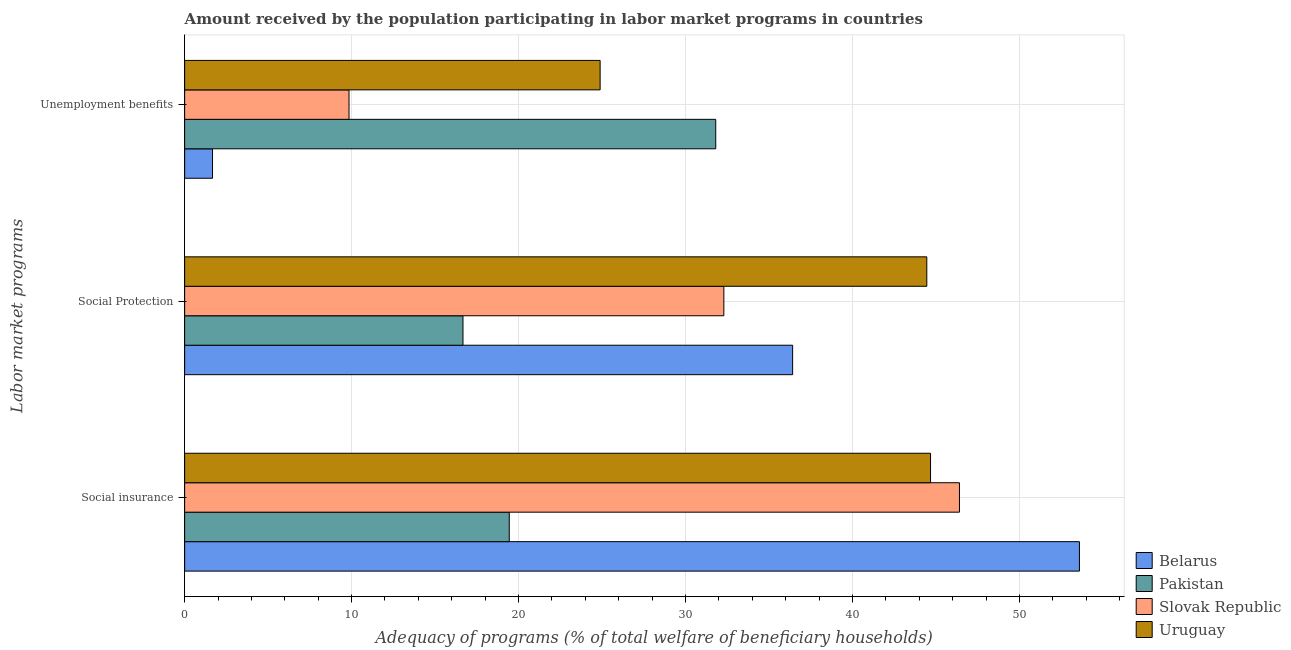How many different coloured bars are there?
Keep it short and to the point. 4. How many groups of bars are there?
Provide a succinct answer. 3. What is the label of the 3rd group of bars from the top?
Give a very brief answer. Social insurance. What is the amount received by the population participating in social protection programs in Pakistan?
Provide a short and direct response. 16.67. Across all countries, what is the maximum amount received by the population participating in social protection programs?
Make the answer very short. 44.45. Across all countries, what is the minimum amount received by the population participating in social insurance programs?
Provide a short and direct response. 19.44. In which country was the amount received by the population participating in social protection programs maximum?
Keep it short and to the point. Uruguay. In which country was the amount received by the population participating in unemployment benefits programs minimum?
Your answer should be compact. Belarus. What is the total amount received by the population participating in social insurance programs in the graph?
Ensure brevity in your answer.  164.13. What is the difference between the amount received by the population participating in social protection programs in Pakistan and that in Uruguay?
Ensure brevity in your answer.  -27.78. What is the difference between the amount received by the population participating in social insurance programs in Slovak Republic and the amount received by the population participating in social protection programs in Uruguay?
Your answer should be compact. 1.96. What is the average amount received by the population participating in unemployment benefits programs per country?
Provide a short and direct response. 17.05. What is the difference between the amount received by the population participating in unemployment benefits programs and amount received by the population participating in social insurance programs in Slovak Republic?
Offer a very short reply. -36.56. In how many countries, is the amount received by the population participating in social protection programs greater than 48 %?
Offer a very short reply. 0. What is the ratio of the amount received by the population participating in social insurance programs in Uruguay to that in Pakistan?
Offer a very short reply. 2.3. Is the difference between the amount received by the population participating in social protection programs in Slovak Republic and Pakistan greater than the difference between the amount received by the population participating in unemployment benefits programs in Slovak Republic and Pakistan?
Offer a terse response. Yes. What is the difference between the highest and the second highest amount received by the population participating in social insurance programs?
Offer a very short reply. 7.19. What is the difference between the highest and the lowest amount received by the population participating in social insurance programs?
Offer a terse response. 34.15. In how many countries, is the amount received by the population participating in unemployment benefits programs greater than the average amount received by the population participating in unemployment benefits programs taken over all countries?
Give a very brief answer. 2. Is the sum of the amount received by the population participating in unemployment benefits programs in Slovak Republic and Belarus greater than the maximum amount received by the population participating in social insurance programs across all countries?
Offer a terse response. No. What does the 1st bar from the top in Unemployment benefits represents?
Your answer should be very brief. Uruguay. What does the 1st bar from the bottom in Social insurance represents?
Provide a succinct answer. Belarus. Are all the bars in the graph horizontal?
Your answer should be compact. Yes. How many countries are there in the graph?
Ensure brevity in your answer.  4. Does the graph contain any zero values?
Provide a short and direct response. No. Where does the legend appear in the graph?
Give a very brief answer. Bottom right. How many legend labels are there?
Your response must be concise. 4. What is the title of the graph?
Give a very brief answer. Amount received by the population participating in labor market programs in countries. What is the label or title of the X-axis?
Provide a short and direct response. Adequacy of programs (% of total welfare of beneficiary households). What is the label or title of the Y-axis?
Offer a terse response. Labor market programs. What is the Adequacy of programs (% of total welfare of beneficiary households) in Belarus in Social insurance?
Make the answer very short. 53.6. What is the Adequacy of programs (% of total welfare of beneficiary households) in Pakistan in Social insurance?
Offer a terse response. 19.44. What is the Adequacy of programs (% of total welfare of beneficiary households) of Slovak Republic in Social insurance?
Your response must be concise. 46.41. What is the Adequacy of programs (% of total welfare of beneficiary households) of Uruguay in Social insurance?
Give a very brief answer. 44.68. What is the Adequacy of programs (% of total welfare of beneficiary households) of Belarus in Social Protection?
Offer a very short reply. 36.42. What is the Adequacy of programs (% of total welfare of beneficiary households) in Pakistan in Social Protection?
Provide a short and direct response. 16.67. What is the Adequacy of programs (% of total welfare of beneficiary households) in Slovak Republic in Social Protection?
Offer a very short reply. 32.3. What is the Adequacy of programs (% of total welfare of beneficiary households) of Uruguay in Social Protection?
Your answer should be compact. 44.45. What is the Adequacy of programs (% of total welfare of beneficiary households) in Belarus in Unemployment benefits?
Ensure brevity in your answer.  1.67. What is the Adequacy of programs (% of total welfare of beneficiary households) of Pakistan in Unemployment benefits?
Provide a succinct answer. 31.81. What is the Adequacy of programs (% of total welfare of beneficiary households) of Slovak Republic in Unemployment benefits?
Offer a very short reply. 9.85. What is the Adequacy of programs (% of total welfare of beneficiary households) in Uruguay in Unemployment benefits?
Offer a very short reply. 24.89. Across all Labor market programs, what is the maximum Adequacy of programs (% of total welfare of beneficiary households) of Belarus?
Your answer should be very brief. 53.6. Across all Labor market programs, what is the maximum Adequacy of programs (% of total welfare of beneficiary households) in Pakistan?
Give a very brief answer. 31.81. Across all Labor market programs, what is the maximum Adequacy of programs (% of total welfare of beneficiary households) in Slovak Republic?
Ensure brevity in your answer.  46.41. Across all Labor market programs, what is the maximum Adequacy of programs (% of total welfare of beneficiary households) in Uruguay?
Offer a very short reply. 44.68. Across all Labor market programs, what is the minimum Adequacy of programs (% of total welfare of beneficiary households) in Belarus?
Keep it short and to the point. 1.67. Across all Labor market programs, what is the minimum Adequacy of programs (% of total welfare of beneficiary households) in Pakistan?
Ensure brevity in your answer.  16.67. Across all Labor market programs, what is the minimum Adequacy of programs (% of total welfare of beneficiary households) in Slovak Republic?
Offer a terse response. 9.85. Across all Labor market programs, what is the minimum Adequacy of programs (% of total welfare of beneficiary households) of Uruguay?
Your response must be concise. 24.89. What is the total Adequacy of programs (% of total welfare of beneficiary households) of Belarus in the graph?
Provide a succinct answer. 91.68. What is the total Adequacy of programs (% of total welfare of beneficiary households) of Pakistan in the graph?
Your answer should be compact. 67.93. What is the total Adequacy of programs (% of total welfare of beneficiary households) of Slovak Republic in the graph?
Your answer should be compact. 88.55. What is the total Adequacy of programs (% of total welfare of beneficiary households) in Uruguay in the graph?
Offer a terse response. 114.02. What is the difference between the Adequacy of programs (% of total welfare of beneficiary households) of Belarus in Social insurance and that in Social Protection?
Provide a short and direct response. 17.18. What is the difference between the Adequacy of programs (% of total welfare of beneficiary households) of Pakistan in Social insurance and that in Social Protection?
Your answer should be compact. 2.77. What is the difference between the Adequacy of programs (% of total welfare of beneficiary households) in Slovak Republic in Social insurance and that in Social Protection?
Your answer should be very brief. 14.11. What is the difference between the Adequacy of programs (% of total welfare of beneficiary households) in Uruguay in Social insurance and that in Social Protection?
Provide a short and direct response. 0.22. What is the difference between the Adequacy of programs (% of total welfare of beneficiary households) of Belarus in Social insurance and that in Unemployment benefits?
Give a very brief answer. 51.93. What is the difference between the Adequacy of programs (% of total welfare of beneficiary households) of Pakistan in Social insurance and that in Unemployment benefits?
Offer a very short reply. -12.37. What is the difference between the Adequacy of programs (% of total welfare of beneficiary households) in Slovak Republic in Social insurance and that in Unemployment benefits?
Make the answer very short. 36.56. What is the difference between the Adequacy of programs (% of total welfare of beneficiary households) of Uruguay in Social insurance and that in Unemployment benefits?
Keep it short and to the point. 19.79. What is the difference between the Adequacy of programs (% of total welfare of beneficiary households) in Belarus in Social Protection and that in Unemployment benefits?
Your answer should be compact. 34.75. What is the difference between the Adequacy of programs (% of total welfare of beneficiary households) of Pakistan in Social Protection and that in Unemployment benefits?
Your response must be concise. -15.14. What is the difference between the Adequacy of programs (% of total welfare of beneficiary households) in Slovak Republic in Social Protection and that in Unemployment benefits?
Offer a terse response. 22.45. What is the difference between the Adequacy of programs (% of total welfare of beneficiary households) of Uruguay in Social Protection and that in Unemployment benefits?
Provide a succinct answer. 19.57. What is the difference between the Adequacy of programs (% of total welfare of beneficiary households) of Belarus in Social insurance and the Adequacy of programs (% of total welfare of beneficiary households) of Pakistan in Social Protection?
Your answer should be compact. 36.92. What is the difference between the Adequacy of programs (% of total welfare of beneficiary households) in Belarus in Social insurance and the Adequacy of programs (% of total welfare of beneficiary households) in Slovak Republic in Social Protection?
Provide a succinct answer. 21.3. What is the difference between the Adequacy of programs (% of total welfare of beneficiary households) of Belarus in Social insurance and the Adequacy of programs (% of total welfare of beneficiary households) of Uruguay in Social Protection?
Ensure brevity in your answer.  9.14. What is the difference between the Adequacy of programs (% of total welfare of beneficiary households) in Pakistan in Social insurance and the Adequacy of programs (% of total welfare of beneficiary households) in Slovak Republic in Social Protection?
Make the answer very short. -12.85. What is the difference between the Adequacy of programs (% of total welfare of beneficiary households) in Pakistan in Social insurance and the Adequacy of programs (% of total welfare of beneficiary households) in Uruguay in Social Protection?
Your answer should be compact. -25.01. What is the difference between the Adequacy of programs (% of total welfare of beneficiary households) of Slovak Republic in Social insurance and the Adequacy of programs (% of total welfare of beneficiary households) of Uruguay in Social Protection?
Make the answer very short. 1.96. What is the difference between the Adequacy of programs (% of total welfare of beneficiary households) in Belarus in Social insurance and the Adequacy of programs (% of total welfare of beneficiary households) in Pakistan in Unemployment benefits?
Offer a terse response. 21.79. What is the difference between the Adequacy of programs (% of total welfare of beneficiary households) of Belarus in Social insurance and the Adequacy of programs (% of total welfare of beneficiary households) of Slovak Republic in Unemployment benefits?
Your response must be concise. 43.75. What is the difference between the Adequacy of programs (% of total welfare of beneficiary households) of Belarus in Social insurance and the Adequacy of programs (% of total welfare of beneficiary households) of Uruguay in Unemployment benefits?
Ensure brevity in your answer.  28.71. What is the difference between the Adequacy of programs (% of total welfare of beneficiary households) in Pakistan in Social insurance and the Adequacy of programs (% of total welfare of beneficiary households) in Slovak Republic in Unemployment benefits?
Provide a short and direct response. 9.6. What is the difference between the Adequacy of programs (% of total welfare of beneficiary households) in Pakistan in Social insurance and the Adequacy of programs (% of total welfare of beneficiary households) in Uruguay in Unemployment benefits?
Ensure brevity in your answer.  -5.44. What is the difference between the Adequacy of programs (% of total welfare of beneficiary households) in Slovak Republic in Social insurance and the Adequacy of programs (% of total welfare of beneficiary households) in Uruguay in Unemployment benefits?
Provide a short and direct response. 21.52. What is the difference between the Adequacy of programs (% of total welfare of beneficiary households) in Belarus in Social Protection and the Adequacy of programs (% of total welfare of beneficiary households) in Pakistan in Unemployment benefits?
Provide a succinct answer. 4.61. What is the difference between the Adequacy of programs (% of total welfare of beneficiary households) in Belarus in Social Protection and the Adequacy of programs (% of total welfare of beneficiary households) in Slovak Republic in Unemployment benefits?
Make the answer very short. 26.57. What is the difference between the Adequacy of programs (% of total welfare of beneficiary households) of Belarus in Social Protection and the Adequacy of programs (% of total welfare of beneficiary households) of Uruguay in Unemployment benefits?
Make the answer very short. 11.53. What is the difference between the Adequacy of programs (% of total welfare of beneficiary households) in Pakistan in Social Protection and the Adequacy of programs (% of total welfare of beneficiary households) in Slovak Republic in Unemployment benefits?
Make the answer very short. 6.83. What is the difference between the Adequacy of programs (% of total welfare of beneficiary households) of Pakistan in Social Protection and the Adequacy of programs (% of total welfare of beneficiary households) of Uruguay in Unemployment benefits?
Your answer should be compact. -8.21. What is the difference between the Adequacy of programs (% of total welfare of beneficiary households) of Slovak Republic in Social Protection and the Adequacy of programs (% of total welfare of beneficiary households) of Uruguay in Unemployment benefits?
Your answer should be compact. 7.41. What is the average Adequacy of programs (% of total welfare of beneficiary households) of Belarus per Labor market programs?
Provide a short and direct response. 30.56. What is the average Adequacy of programs (% of total welfare of beneficiary households) of Pakistan per Labor market programs?
Offer a terse response. 22.64. What is the average Adequacy of programs (% of total welfare of beneficiary households) in Slovak Republic per Labor market programs?
Offer a terse response. 29.52. What is the average Adequacy of programs (% of total welfare of beneficiary households) in Uruguay per Labor market programs?
Make the answer very short. 38.01. What is the difference between the Adequacy of programs (% of total welfare of beneficiary households) in Belarus and Adequacy of programs (% of total welfare of beneficiary households) in Pakistan in Social insurance?
Make the answer very short. 34.15. What is the difference between the Adequacy of programs (% of total welfare of beneficiary households) in Belarus and Adequacy of programs (% of total welfare of beneficiary households) in Slovak Republic in Social insurance?
Your response must be concise. 7.19. What is the difference between the Adequacy of programs (% of total welfare of beneficiary households) of Belarus and Adequacy of programs (% of total welfare of beneficiary households) of Uruguay in Social insurance?
Offer a very short reply. 8.92. What is the difference between the Adequacy of programs (% of total welfare of beneficiary households) in Pakistan and Adequacy of programs (% of total welfare of beneficiary households) in Slovak Republic in Social insurance?
Your response must be concise. -26.97. What is the difference between the Adequacy of programs (% of total welfare of beneficiary households) in Pakistan and Adequacy of programs (% of total welfare of beneficiary households) in Uruguay in Social insurance?
Offer a very short reply. -25.23. What is the difference between the Adequacy of programs (% of total welfare of beneficiary households) of Slovak Republic and Adequacy of programs (% of total welfare of beneficiary households) of Uruguay in Social insurance?
Offer a terse response. 1.73. What is the difference between the Adequacy of programs (% of total welfare of beneficiary households) of Belarus and Adequacy of programs (% of total welfare of beneficiary households) of Pakistan in Social Protection?
Make the answer very short. 19.75. What is the difference between the Adequacy of programs (% of total welfare of beneficiary households) in Belarus and Adequacy of programs (% of total welfare of beneficiary households) in Slovak Republic in Social Protection?
Offer a terse response. 4.12. What is the difference between the Adequacy of programs (% of total welfare of beneficiary households) of Belarus and Adequacy of programs (% of total welfare of beneficiary households) of Uruguay in Social Protection?
Offer a terse response. -8.04. What is the difference between the Adequacy of programs (% of total welfare of beneficiary households) of Pakistan and Adequacy of programs (% of total welfare of beneficiary households) of Slovak Republic in Social Protection?
Make the answer very short. -15.63. What is the difference between the Adequacy of programs (% of total welfare of beneficiary households) in Pakistan and Adequacy of programs (% of total welfare of beneficiary households) in Uruguay in Social Protection?
Offer a terse response. -27.78. What is the difference between the Adequacy of programs (% of total welfare of beneficiary households) of Slovak Republic and Adequacy of programs (% of total welfare of beneficiary households) of Uruguay in Social Protection?
Your answer should be compact. -12.16. What is the difference between the Adequacy of programs (% of total welfare of beneficiary households) in Belarus and Adequacy of programs (% of total welfare of beneficiary households) in Pakistan in Unemployment benefits?
Your response must be concise. -30.14. What is the difference between the Adequacy of programs (% of total welfare of beneficiary households) in Belarus and Adequacy of programs (% of total welfare of beneficiary households) in Slovak Republic in Unemployment benefits?
Ensure brevity in your answer.  -8.18. What is the difference between the Adequacy of programs (% of total welfare of beneficiary households) in Belarus and Adequacy of programs (% of total welfare of beneficiary households) in Uruguay in Unemployment benefits?
Your answer should be very brief. -23.22. What is the difference between the Adequacy of programs (% of total welfare of beneficiary households) of Pakistan and Adequacy of programs (% of total welfare of beneficiary households) of Slovak Republic in Unemployment benefits?
Offer a very short reply. 21.97. What is the difference between the Adequacy of programs (% of total welfare of beneficiary households) of Pakistan and Adequacy of programs (% of total welfare of beneficiary households) of Uruguay in Unemployment benefits?
Your answer should be very brief. 6.92. What is the difference between the Adequacy of programs (% of total welfare of beneficiary households) in Slovak Republic and Adequacy of programs (% of total welfare of beneficiary households) in Uruguay in Unemployment benefits?
Give a very brief answer. -15.04. What is the ratio of the Adequacy of programs (% of total welfare of beneficiary households) in Belarus in Social insurance to that in Social Protection?
Provide a short and direct response. 1.47. What is the ratio of the Adequacy of programs (% of total welfare of beneficiary households) in Pakistan in Social insurance to that in Social Protection?
Provide a succinct answer. 1.17. What is the ratio of the Adequacy of programs (% of total welfare of beneficiary households) of Slovak Republic in Social insurance to that in Social Protection?
Provide a succinct answer. 1.44. What is the ratio of the Adequacy of programs (% of total welfare of beneficiary households) in Belarus in Social insurance to that in Unemployment benefits?
Give a very brief answer. 32.09. What is the ratio of the Adequacy of programs (% of total welfare of beneficiary households) in Pakistan in Social insurance to that in Unemployment benefits?
Provide a short and direct response. 0.61. What is the ratio of the Adequacy of programs (% of total welfare of beneficiary households) of Slovak Republic in Social insurance to that in Unemployment benefits?
Make the answer very short. 4.71. What is the ratio of the Adequacy of programs (% of total welfare of beneficiary households) in Uruguay in Social insurance to that in Unemployment benefits?
Your answer should be very brief. 1.8. What is the ratio of the Adequacy of programs (% of total welfare of beneficiary households) of Belarus in Social Protection to that in Unemployment benefits?
Make the answer very short. 21.8. What is the ratio of the Adequacy of programs (% of total welfare of beneficiary households) in Pakistan in Social Protection to that in Unemployment benefits?
Your answer should be compact. 0.52. What is the ratio of the Adequacy of programs (% of total welfare of beneficiary households) of Slovak Republic in Social Protection to that in Unemployment benefits?
Your answer should be compact. 3.28. What is the ratio of the Adequacy of programs (% of total welfare of beneficiary households) of Uruguay in Social Protection to that in Unemployment benefits?
Provide a succinct answer. 1.79. What is the difference between the highest and the second highest Adequacy of programs (% of total welfare of beneficiary households) in Belarus?
Your answer should be very brief. 17.18. What is the difference between the highest and the second highest Adequacy of programs (% of total welfare of beneficiary households) in Pakistan?
Give a very brief answer. 12.37. What is the difference between the highest and the second highest Adequacy of programs (% of total welfare of beneficiary households) in Slovak Republic?
Your answer should be compact. 14.11. What is the difference between the highest and the second highest Adequacy of programs (% of total welfare of beneficiary households) in Uruguay?
Ensure brevity in your answer.  0.22. What is the difference between the highest and the lowest Adequacy of programs (% of total welfare of beneficiary households) in Belarus?
Make the answer very short. 51.93. What is the difference between the highest and the lowest Adequacy of programs (% of total welfare of beneficiary households) in Pakistan?
Keep it short and to the point. 15.14. What is the difference between the highest and the lowest Adequacy of programs (% of total welfare of beneficiary households) of Slovak Republic?
Provide a succinct answer. 36.56. What is the difference between the highest and the lowest Adequacy of programs (% of total welfare of beneficiary households) of Uruguay?
Keep it short and to the point. 19.79. 